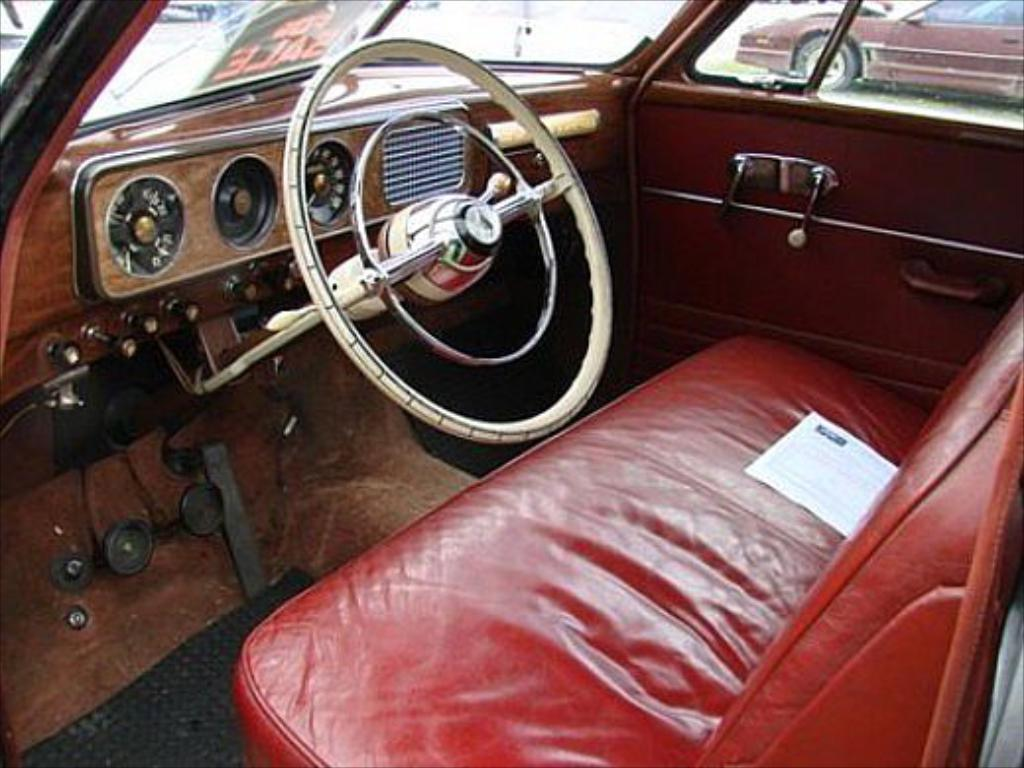What type of setting is depicted in the image? The image is an inside view of a car. What color is the seat visible in the car? There is a red color seat in the car. What is the primary control mechanism for driving the car? There is a steering wheel in the car. What can be seen through the windows of the car? The car windows are visible. What is visible in the background of the image? There is another car in the background. What year is the car in the image approved for use? The provided facts do not mention the year or approval status of the car, so it cannot be determined from the image. 